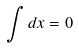<formula> <loc_0><loc_0><loc_500><loc_500>\int d x = 0</formula> 